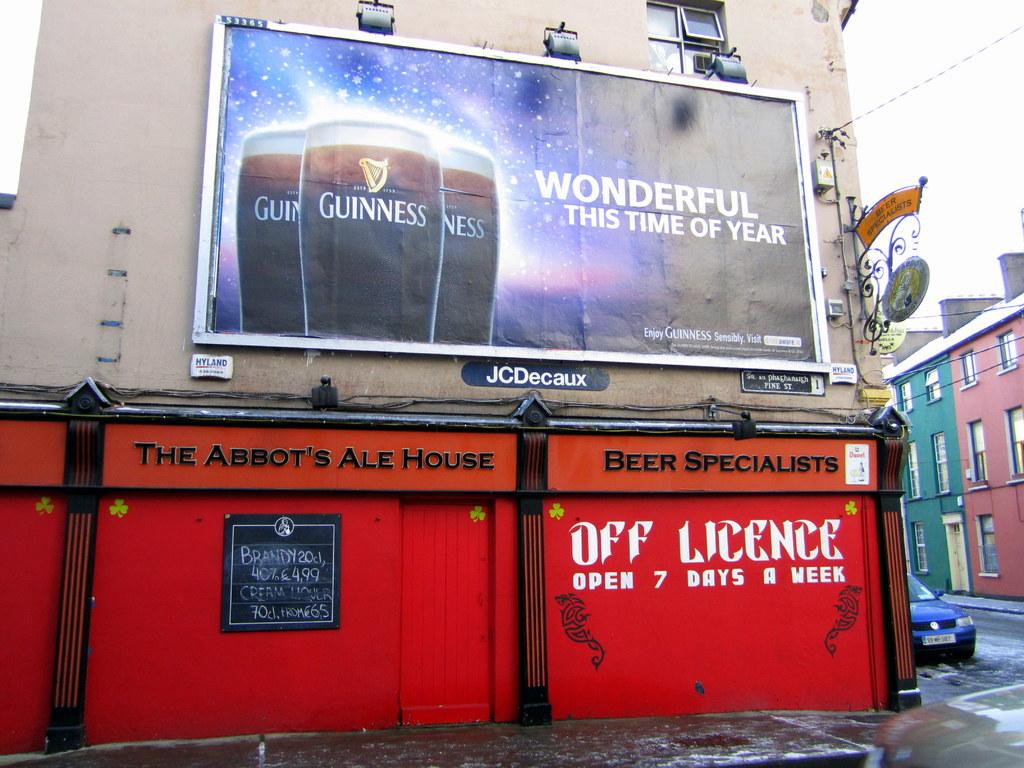How many days a week is the red place open?
Keep it short and to the point. 7. 